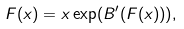<formula> <loc_0><loc_0><loc_500><loc_500>F ( x ) = x \exp ( B ^ { \prime } ( F ( x ) ) ) ,</formula> 